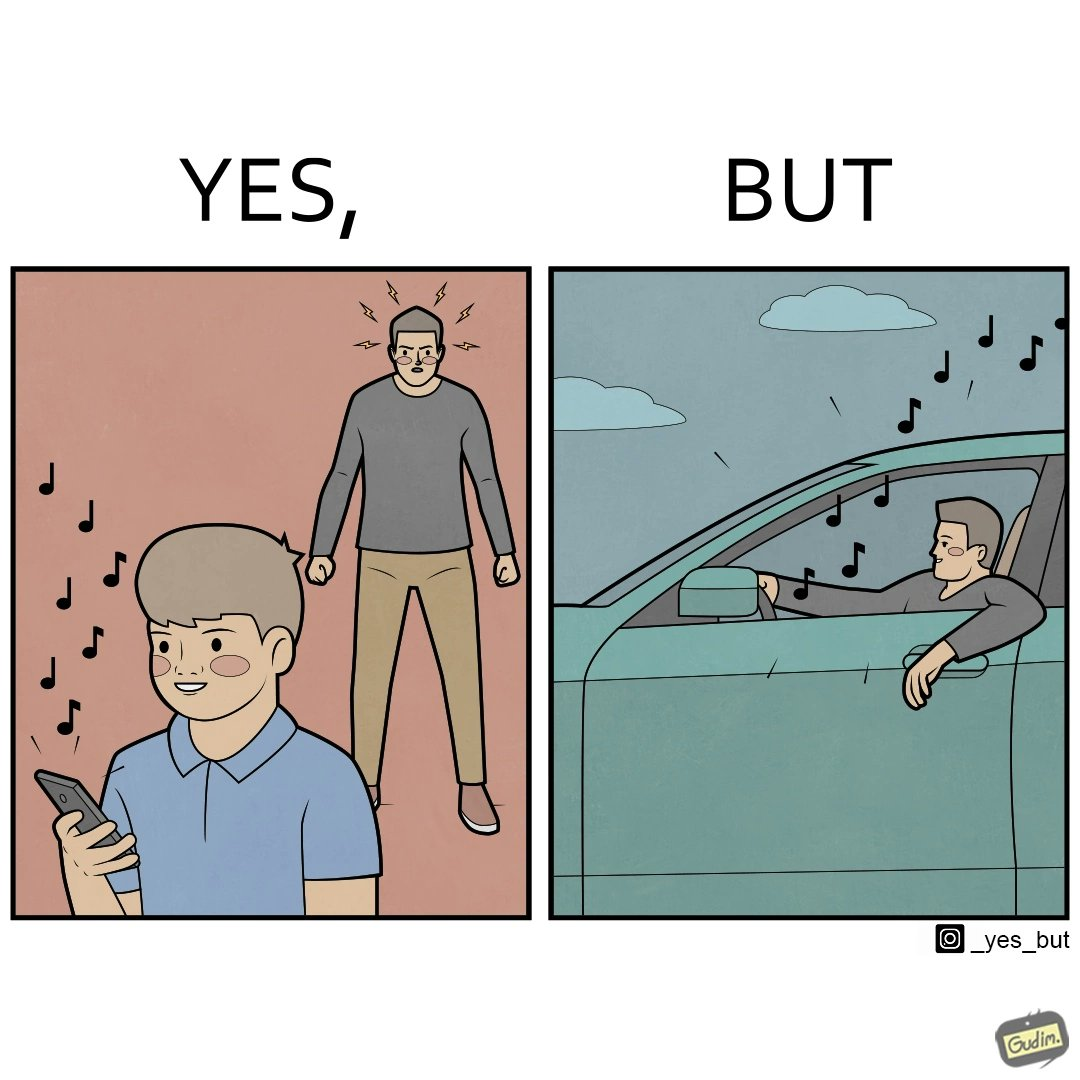What does this image depict? The image is funny because while the man does not like the boy playing music loudly on his phone, the man himself is okay with doing the same thing with his car and playing loud music in the car with the sound coming out of the car. 